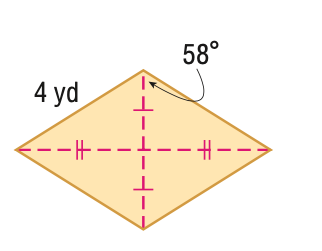Question: Find the area of the figure in feet. Round to the nearest tenth, if necessary.
Choices:
A. 14.4
B. 16
C. 28.8
D. 32
Answer with the letter. Answer: A 